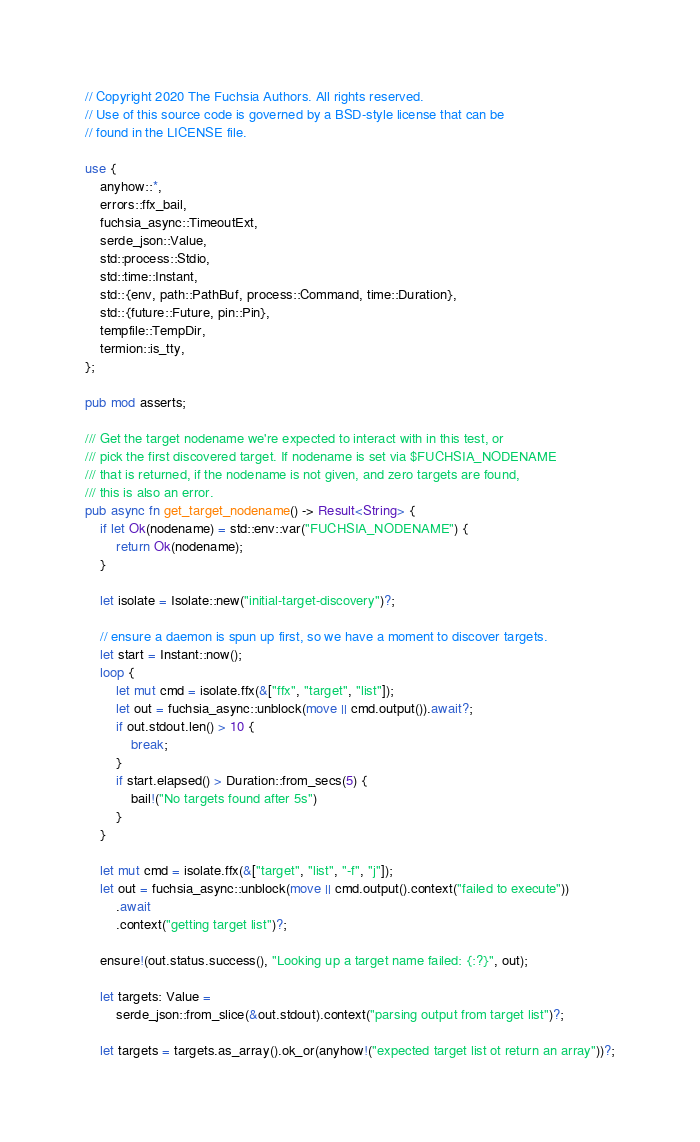Convert code to text. <code><loc_0><loc_0><loc_500><loc_500><_Rust_>// Copyright 2020 The Fuchsia Authors. All rights reserved.
// Use of this source code is governed by a BSD-style license that can be
// found in the LICENSE file.

use {
    anyhow::*,
    errors::ffx_bail,
    fuchsia_async::TimeoutExt,
    serde_json::Value,
    std::process::Stdio,
    std::time::Instant,
    std::{env, path::PathBuf, process::Command, time::Duration},
    std::{future::Future, pin::Pin},
    tempfile::TempDir,
    termion::is_tty,
};

pub mod asserts;

/// Get the target nodename we're expected to interact with in this test, or
/// pick the first discovered target. If nodename is set via $FUCHSIA_NODENAME
/// that is returned, if the nodename is not given, and zero targets are found,
/// this is also an error.
pub async fn get_target_nodename() -> Result<String> {
    if let Ok(nodename) = std::env::var("FUCHSIA_NODENAME") {
        return Ok(nodename);
    }

    let isolate = Isolate::new("initial-target-discovery")?;

    // ensure a daemon is spun up first, so we have a moment to discover targets.
    let start = Instant::now();
    loop {
        let mut cmd = isolate.ffx(&["ffx", "target", "list"]);
        let out = fuchsia_async::unblock(move || cmd.output()).await?;
        if out.stdout.len() > 10 {
            break;
        }
        if start.elapsed() > Duration::from_secs(5) {
            bail!("No targets found after 5s")
        }
    }

    let mut cmd = isolate.ffx(&["target", "list", "-f", "j"]);
    let out = fuchsia_async::unblock(move || cmd.output().context("failed to execute"))
        .await
        .context("getting target list")?;

    ensure!(out.status.success(), "Looking up a target name failed: {:?}", out);

    let targets: Value =
        serde_json::from_slice(&out.stdout).context("parsing output from target list")?;

    let targets = targets.as_array().ok_or(anyhow!("expected target list ot return an array"))?;
</code> 